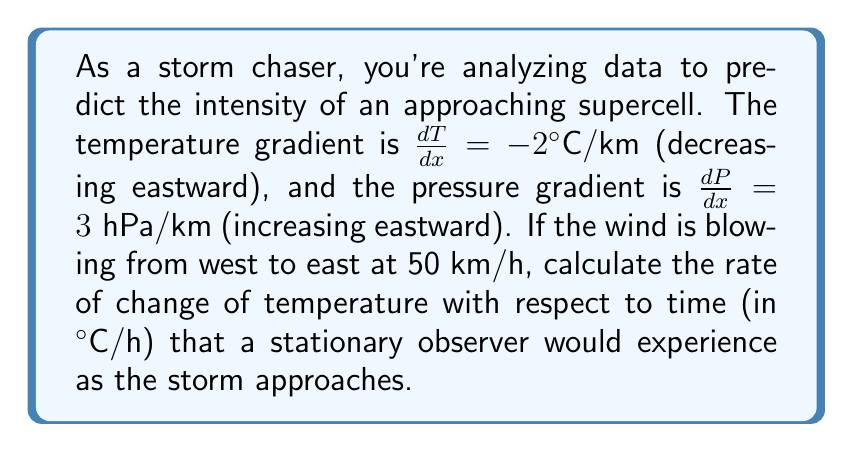What is the answer to this math problem? To solve this problem, we'll use the chain rule and the given information:

1) The rate of change of temperature with respect to time can be expressed as:

   $$\frac{dT}{dt} = \frac{dT}{dx} \cdot \frac{dx}{dt}$$

2) We're given $\frac{dT}{dx} = -2°C/km$

3) We need to find $\frac{dx}{dt}$, which is the wind speed:
   - The wind is blowing from west to east at 50 km/h
   - This means $\frac{dx}{dt} = 50 \text{ km/h}$

4) Now we can substitute these values into our equation:

   $$\frac{dT}{dt} = (-2°C/km) \cdot (50 \text{ km/h})$$

5) Simplify:
   $$\frac{dT}{dt} = -100°C/h$$

Therefore, a stationary observer would experience a temperature decrease of 100°C per hour as the storm approaches.

Note: While this rate seems extreme, it's a simplified model for illustrative purposes. In real-world scenarios, other factors would influence the actual temperature change.
Answer: $-100°C/h$ 